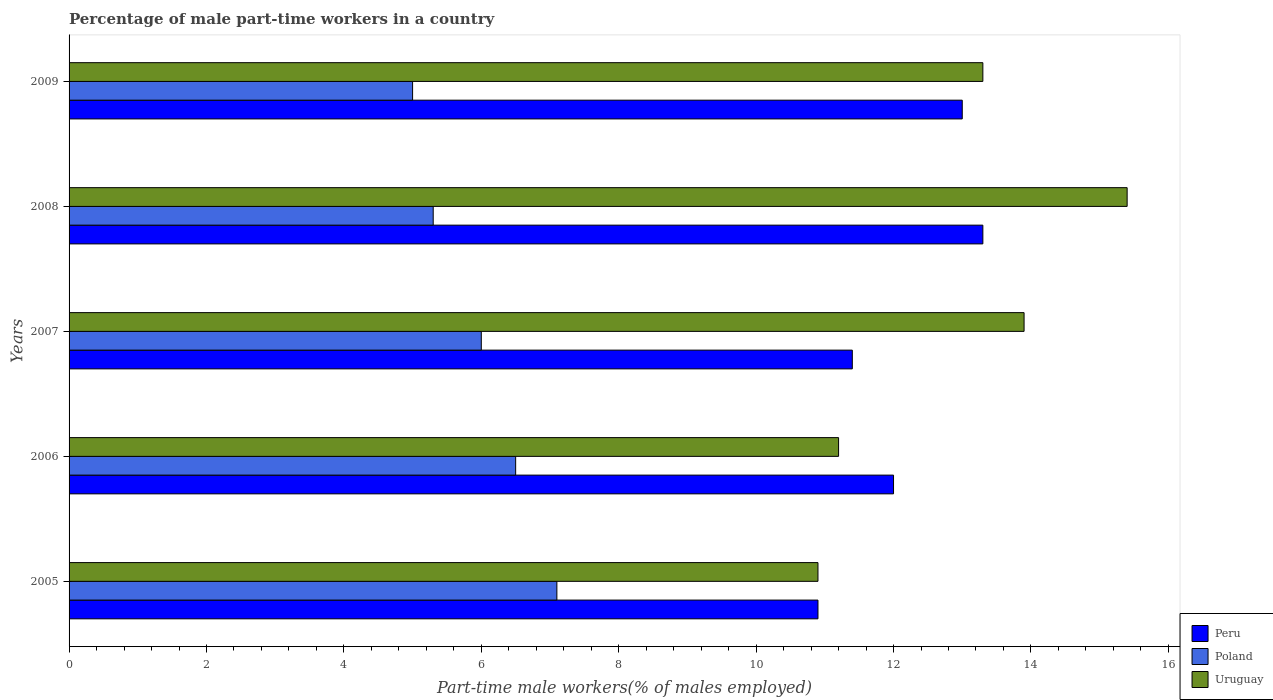How many different coloured bars are there?
Offer a very short reply. 3. How many groups of bars are there?
Your answer should be compact. 5. In how many cases, is the number of bars for a given year not equal to the number of legend labels?
Offer a very short reply. 0. What is the percentage of male part-time workers in Uruguay in 2006?
Your response must be concise. 11.2. Across all years, what is the maximum percentage of male part-time workers in Peru?
Give a very brief answer. 13.3. Across all years, what is the minimum percentage of male part-time workers in Uruguay?
Your answer should be very brief. 10.9. In which year was the percentage of male part-time workers in Uruguay minimum?
Provide a short and direct response. 2005. What is the total percentage of male part-time workers in Peru in the graph?
Provide a short and direct response. 60.6. What is the difference between the percentage of male part-time workers in Poland in 2005 and that in 2009?
Offer a very short reply. 2.1. What is the difference between the percentage of male part-time workers in Poland in 2008 and the percentage of male part-time workers in Uruguay in 2007?
Offer a terse response. -8.6. What is the average percentage of male part-time workers in Peru per year?
Your answer should be very brief. 12.12. In how many years, is the percentage of male part-time workers in Uruguay greater than 11.2 %?
Offer a terse response. 3. What is the ratio of the percentage of male part-time workers in Peru in 2005 to that in 2006?
Your answer should be compact. 0.91. Is the percentage of male part-time workers in Poland in 2005 less than that in 2009?
Your response must be concise. No. What is the difference between the highest and the second highest percentage of male part-time workers in Peru?
Your answer should be very brief. 0.3. What does the 2nd bar from the top in 2008 represents?
Give a very brief answer. Poland. What does the 3rd bar from the bottom in 2009 represents?
Offer a very short reply. Uruguay. How many bars are there?
Offer a terse response. 15. Are all the bars in the graph horizontal?
Keep it short and to the point. Yes. What is the difference between two consecutive major ticks on the X-axis?
Offer a terse response. 2. Does the graph contain grids?
Ensure brevity in your answer.  No. How are the legend labels stacked?
Keep it short and to the point. Vertical. What is the title of the graph?
Your response must be concise. Percentage of male part-time workers in a country. What is the label or title of the X-axis?
Provide a short and direct response. Part-time male workers(% of males employed). What is the Part-time male workers(% of males employed) of Peru in 2005?
Your response must be concise. 10.9. What is the Part-time male workers(% of males employed) of Poland in 2005?
Keep it short and to the point. 7.1. What is the Part-time male workers(% of males employed) of Uruguay in 2005?
Offer a very short reply. 10.9. What is the Part-time male workers(% of males employed) in Uruguay in 2006?
Offer a very short reply. 11.2. What is the Part-time male workers(% of males employed) of Peru in 2007?
Your response must be concise. 11.4. What is the Part-time male workers(% of males employed) of Uruguay in 2007?
Offer a very short reply. 13.9. What is the Part-time male workers(% of males employed) in Peru in 2008?
Keep it short and to the point. 13.3. What is the Part-time male workers(% of males employed) of Poland in 2008?
Your answer should be very brief. 5.3. What is the Part-time male workers(% of males employed) of Uruguay in 2008?
Offer a very short reply. 15.4. What is the Part-time male workers(% of males employed) in Poland in 2009?
Provide a succinct answer. 5. What is the Part-time male workers(% of males employed) of Uruguay in 2009?
Give a very brief answer. 13.3. Across all years, what is the maximum Part-time male workers(% of males employed) of Peru?
Offer a very short reply. 13.3. Across all years, what is the maximum Part-time male workers(% of males employed) of Poland?
Ensure brevity in your answer.  7.1. Across all years, what is the maximum Part-time male workers(% of males employed) of Uruguay?
Your answer should be very brief. 15.4. Across all years, what is the minimum Part-time male workers(% of males employed) in Peru?
Offer a very short reply. 10.9. Across all years, what is the minimum Part-time male workers(% of males employed) in Poland?
Keep it short and to the point. 5. Across all years, what is the minimum Part-time male workers(% of males employed) of Uruguay?
Give a very brief answer. 10.9. What is the total Part-time male workers(% of males employed) of Peru in the graph?
Make the answer very short. 60.6. What is the total Part-time male workers(% of males employed) in Poland in the graph?
Your answer should be compact. 29.9. What is the total Part-time male workers(% of males employed) of Uruguay in the graph?
Keep it short and to the point. 64.7. What is the difference between the Part-time male workers(% of males employed) of Peru in 2005 and that in 2006?
Your response must be concise. -1.1. What is the difference between the Part-time male workers(% of males employed) of Poland in 2005 and that in 2007?
Your response must be concise. 1.1. What is the difference between the Part-time male workers(% of males employed) of Uruguay in 2005 and that in 2007?
Provide a short and direct response. -3. What is the difference between the Part-time male workers(% of males employed) of Peru in 2005 and that in 2008?
Offer a very short reply. -2.4. What is the difference between the Part-time male workers(% of males employed) of Uruguay in 2005 and that in 2008?
Make the answer very short. -4.5. What is the difference between the Part-time male workers(% of males employed) in Peru in 2005 and that in 2009?
Offer a terse response. -2.1. What is the difference between the Part-time male workers(% of males employed) in Poland in 2005 and that in 2009?
Keep it short and to the point. 2.1. What is the difference between the Part-time male workers(% of males employed) of Uruguay in 2005 and that in 2009?
Offer a very short reply. -2.4. What is the difference between the Part-time male workers(% of males employed) of Peru in 2006 and that in 2007?
Your answer should be compact. 0.6. What is the difference between the Part-time male workers(% of males employed) of Uruguay in 2006 and that in 2007?
Ensure brevity in your answer.  -2.7. What is the difference between the Part-time male workers(% of males employed) of Poland in 2006 and that in 2008?
Offer a terse response. 1.2. What is the difference between the Part-time male workers(% of males employed) in Peru in 2006 and that in 2009?
Keep it short and to the point. -1. What is the difference between the Part-time male workers(% of males employed) of Poland in 2006 and that in 2009?
Provide a succinct answer. 1.5. What is the difference between the Part-time male workers(% of males employed) of Uruguay in 2006 and that in 2009?
Your answer should be compact. -2.1. What is the difference between the Part-time male workers(% of males employed) of Peru in 2007 and that in 2008?
Your answer should be very brief. -1.9. What is the difference between the Part-time male workers(% of males employed) of Poland in 2007 and that in 2009?
Provide a short and direct response. 1. What is the difference between the Part-time male workers(% of males employed) of Peru in 2008 and that in 2009?
Provide a short and direct response. 0.3. What is the difference between the Part-time male workers(% of males employed) of Peru in 2005 and the Part-time male workers(% of males employed) of Poland in 2006?
Make the answer very short. 4.4. What is the difference between the Part-time male workers(% of males employed) of Peru in 2005 and the Part-time male workers(% of males employed) of Uruguay in 2006?
Provide a short and direct response. -0.3. What is the difference between the Part-time male workers(% of males employed) of Peru in 2005 and the Part-time male workers(% of males employed) of Poland in 2007?
Offer a terse response. 4.9. What is the difference between the Part-time male workers(% of males employed) in Peru in 2005 and the Part-time male workers(% of males employed) in Poland in 2008?
Your answer should be compact. 5.6. What is the difference between the Part-time male workers(% of males employed) of Peru in 2005 and the Part-time male workers(% of males employed) of Poland in 2009?
Your answer should be compact. 5.9. What is the difference between the Part-time male workers(% of males employed) of Peru in 2006 and the Part-time male workers(% of males employed) of Poland in 2007?
Make the answer very short. 6. What is the difference between the Part-time male workers(% of males employed) in Peru in 2006 and the Part-time male workers(% of males employed) in Uruguay in 2007?
Your answer should be compact. -1.9. What is the difference between the Part-time male workers(% of males employed) in Peru in 2006 and the Part-time male workers(% of males employed) in Poland in 2008?
Your answer should be compact. 6.7. What is the difference between the Part-time male workers(% of males employed) in Poland in 2006 and the Part-time male workers(% of males employed) in Uruguay in 2008?
Ensure brevity in your answer.  -8.9. What is the difference between the Part-time male workers(% of males employed) of Peru in 2006 and the Part-time male workers(% of males employed) of Poland in 2009?
Give a very brief answer. 7. What is the difference between the Part-time male workers(% of males employed) of Peru in 2007 and the Part-time male workers(% of males employed) of Poland in 2008?
Offer a terse response. 6.1. What is the difference between the Part-time male workers(% of males employed) in Peru in 2007 and the Part-time male workers(% of males employed) in Uruguay in 2008?
Make the answer very short. -4. What is the difference between the Part-time male workers(% of males employed) of Peru in 2007 and the Part-time male workers(% of males employed) of Poland in 2009?
Keep it short and to the point. 6.4. What is the difference between the Part-time male workers(% of males employed) in Peru in 2007 and the Part-time male workers(% of males employed) in Uruguay in 2009?
Your answer should be very brief. -1.9. What is the difference between the Part-time male workers(% of males employed) in Peru in 2008 and the Part-time male workers(% of males employed) in Poland in 2009?
Your answer should be very brief. 8.3. What is the difference between the Part-time male workers(% of males employed) in Peru in 2008 and the Part-time male workers(% of males employed) in Uruguay in 2009?
Offer a very short reply. 0. What is the average Part-time male workers(% of males employed) of Peru per year?
Offer a very short reply. 12.12. What is the average Part-time male workers(% of males employed) of Poland per year?
Offer a very short reply. 5.98. What is the average Part-time male workers(% of males employed) of Uruguay per year?
Offer a terse response. 12.94. In the year 2005, what is the difference between the Part-time male workers(% of males employed) of Peru and Part-time male workers(% of males employed) of Poland?
Provide a succinct answer. 3.8. In the year 2005, what is the difference between the Part-time male workers(% of males employed) of Peru and Part-time male workers(% of males employed) of Uruguay?
Your answer should be very brief. 0. In the year 2005, what is the difference between the Part-time male workers(% of males employed) of Poland and Part-time male workers(% of males employed) of Uruguay?
Your response must be concise. -3.8. In the year 2006, what is the difference between the Part-time male workers(% of males employed) in Peru and Part-time male workers(% of males employed) in Poland?
Provide a short and direct response. 5.5. In the year 2006, what is the difference between the Part-time male workers(% of males employed) of Peru and Part-time male workers(% of males employed) of Uruguay?
Offer a terse response. 0.8. In the year 2006, what is the difference between the Part-time male workers(% of males employed) of Poland and Part-time male workers(% of males employed) of Uruguay?
Your answer should be compact. -4.7. In the year 2007, what is the difference between the Part-time male workers(% of males employed) of Peru and Part-time male workers(% of males employed) of Poland?
Your response must be concise. 5.4. In the year 2007, what is the difference between the Part-time male workers(% of males employed) of Peru and Part-time male workers(% of males employed) of Uruguay?
Provide a succinct answer. -2.5. In the year 2007, what is the difference between the Part-time male workers(% of males employed) in Poland and Part-time male workers(% of males employed) in Uruguay?
Your answer should be compact. -7.9. In the year 2008, what is the difference between the Part-time male workers(% of males employed) in Poland and Part-time male workers(% of males employed) in Uruguay?
Give a very brief answer. -10.1. In the year 2009, what is the difference between the Part-time male workers(% of males employed) in Peru and Part-time male workers(% of males employed) in Poland?
Provide a short and direct response. 8. What is the ratio of the Part-time male workers(% of males employed) in Peru in 2005 to that in 2006?
Offer a very short reply. 0.91. What is the ratio of the Part-time male workers(% of males employed) of Poland in 2005 to that in 2006?
Offer a very short reply. 1.09. What is the ratio of the Part-time male workers(% of males employed) in Uruguay in 2005 to that in 2006?
Your answer should be compact. 0.97. What is the ratio of the Part-time male workers(% of males employed) in Peru in 2005 to that in 2007?
Your answer should be compact. 0.96. What is the ratio of the Part-time male workers(% of males employed) of Poland in 2005 to that in 2007?
Make the answer very short. 1.18. What is the ratio of the Part-time male workers(% of males employed) of Uruguay in 2005 to that in 2007?
Offer a very short reply. 0.78. What is the ratio of the Part-time male workers(% of males employed) of Peru in 2005 to that in 2008?
Provide a succinct answer. 0.82. What is the ratio of the Part-time male workers(% of males employed) of Poland in 2005 to that in 2008?
Offer a very short reply. 1.34. What is the ratio of the Part-time male workers(% of males employed) of Uruguay in 2005 to that in 2008?
Keep it short and to the point. 0.71. What is the ratio of the Part-time male workers(% of males employed) in Peru in 2005 to that in 2009?
Ensure brevity in your answer.  0.84. What is the ratio of the Part-time male workers(% of males employed) in Poland in 2005 to that in 2009?
Give a very brief answer. 1.42. What is the ratio of the Part-time male workers(% of males employed) in Uruguay in 2005 to that in 2009?
Your answer should be compact. 0.82. What is the ratio of the Part-time male workers(% of males employed) in Peru in 2006 to that in 2007?
Your answer should be very brief. 1.05. What is the ratio of the Part-time male workers(% of males employed) of Poland in 2006 to that in 2007?
Make the answer very short. 1.08. What is the ratio of the Part-time male workers(% of males employed) in Uruguay in 2006 to that in 2007?
Your response must be concise. 0.81. What is the ratio of the Part-time male workers(% of males employed) in Peru in 2006 to that in 2008?
Your answer should be very brief. 0.9. What is the ratio of the Part-time male workers(% of males employed) of Poland in 2006 to that in 2008?
Ensure brevity in your answer.  1.23. What is the ratio of the Part-time male workers(% of males employed) in Uruguay in 2006 to that in 2008?
Provide a succinct answer. 0.73. What is the ratio of the Part-time male workers(% of males employed) in Peru in 2006 to that in 2009?
Your answer should be compact. 0.92. What is the ratio of the Part-time male workers(% of males employed) in Poland in 2006 to that in 2009?
Your answer should be very brief. 1.3. What is the ratio of the Part-time male workers(% of males employed) of Uruguay in 2006 to that in 2009?
Provide a succinct answer. 0.84. What is the ratio of the Part-time male workers(% of males employed) in Peru in 2007 to that in 2008?
Give a very brief answer. 0.86. What is the ratio of the Part-time male workers(% of males employed) of Poland in 2007 to that in 2008?
Give a very brief answer. 1.13. What is the ratio of the Part-time male workers(% of males employed) of Uruguay in 2007 to that in 2008?
Offer a terse response. 0.9. What is the ratio of the Part-time male workers(% of males employed) in Peru in 2007 to that in 2009?
Keep it short and to the point. 0.88. What is the ratio of the Part-time male workers(% of males employed) of Poland in 2007 to that in 2009?
Your answer should be compact. 1.2. What is the ratio of the Part-time male workers(% of males employed) of Uruguay in 2007 to that in 2009?
Provide a short and direct response. 1.05. What is the ratio of the Part-time male workers(% of males employed) of Peru in 2008 to that in 2009?
Offer a terse response. 1.02. What is the ratio of the Part-time male workers(% of males employed) of Poland in 2008 to that in 2009?
Give a very brief answer. 1.06. What is the ratio of the Part-time male workers(% of males employed) in Uruguay in 2008 to that in 2009?
Provide a short and direct response. 1.16. What is the difference between the highest and the second highest Part-time male workers(% of males employed) of Uruguay?
Give a very brief answer. 1.5. What is the difference between the highest and the lowest Part-time male workers(% of males employed) of Peru?
Your response must be concise. 2.4. What is the difference between the highest and the lowest Part-time male workers(% of males employed) in Poland?
Offer a terse response. 2.1. What is the difference between the highest and the lowest Part-time male workers(% of males employed) in Uruguay?
Offer a very short reply. 4.5. 